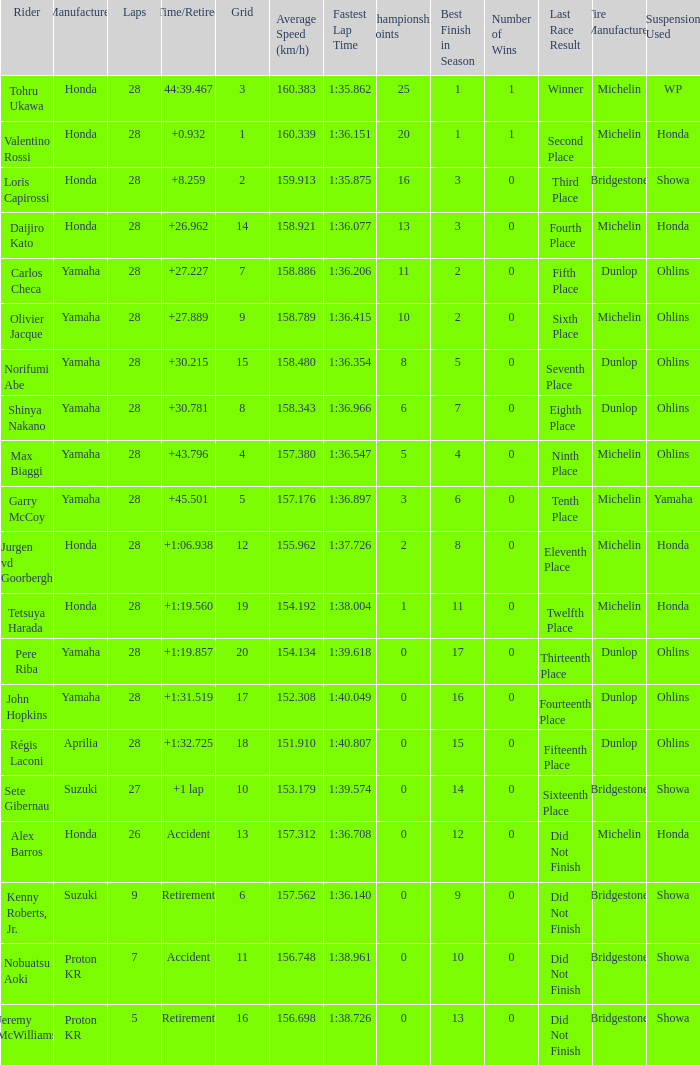Which Grid has Laps larger than 26, and a Time/Retired of 44:39.467? 3.0. 